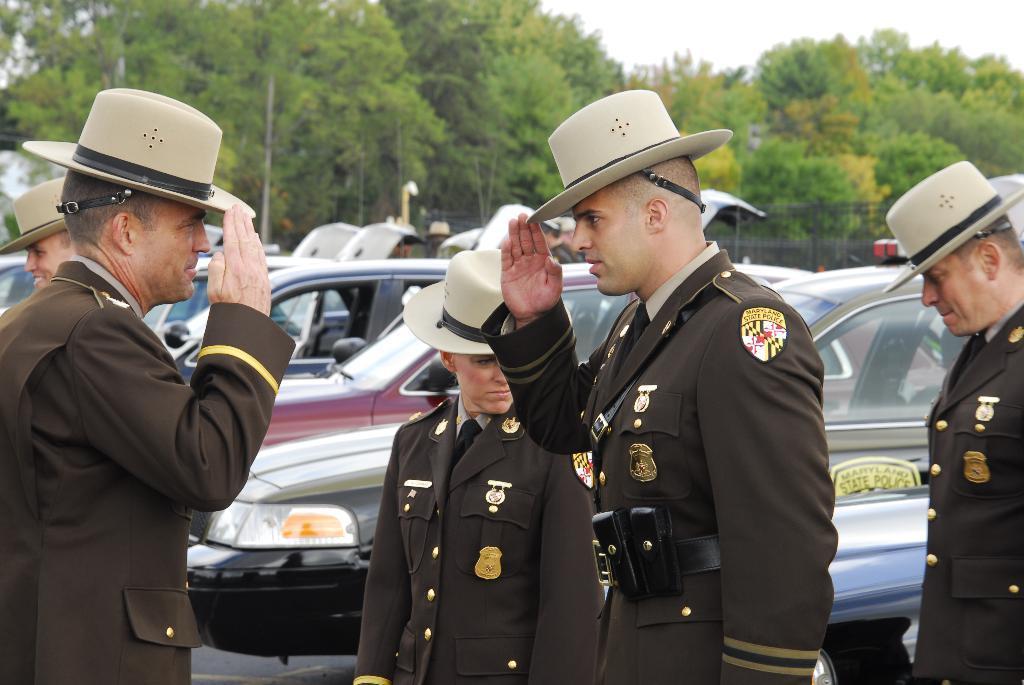Could you give a brief overview of what you see in this image? In the center of the image we can see a few people are standing and they are in different costumes and they are wearing caps. Among them, we can see one person is smiling. In the background, we can see the sky, trees, vehicles and a few other objects. 